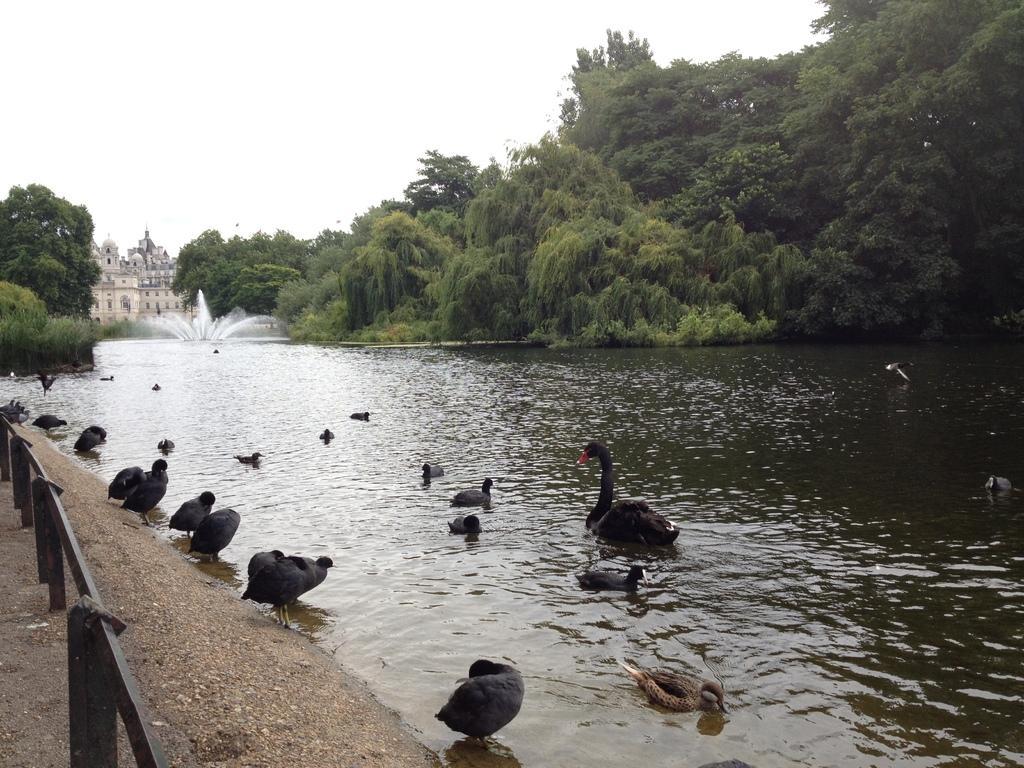Can you describe this image briefly? In this image we can see some birds on the lake. On the left side of the image we can see the fencing with metal rods. On the right side of the image there are trees. In the background there are buildings and sky. In the middle of the lake there is a waterfall. 